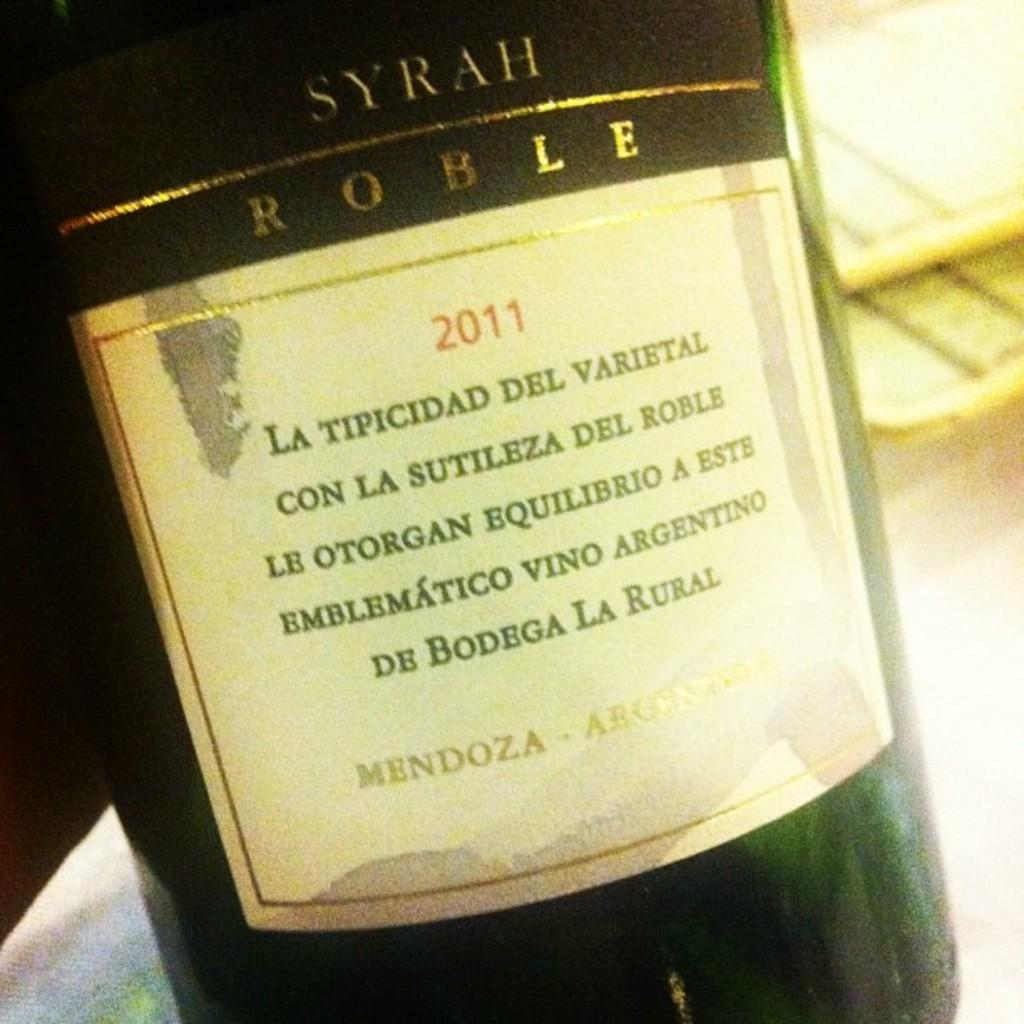Provide a one-sentence caption for the provided image. A bottle of wine has a date of 2011 on the label. 